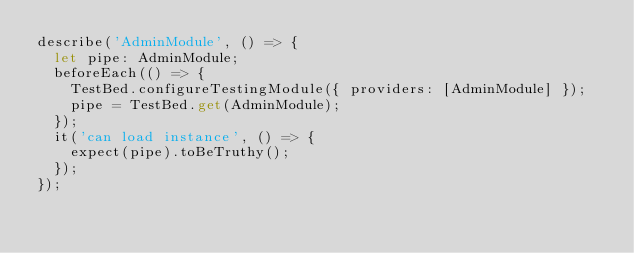<code> <loc_0><loc_0><loc_500><loc_500><_TypeScript_>describe('AdminModule', () => {
  let pipe: AdminModule;
  beforeEach(() => {
    TestBed.configureTestingModule({ providers: [AdminModule] });
    pipe = TestBed.get(AdminModule);
  });
  it('can load instance', () => {
    expect(pipe).toBeTruthy();
  });
});
</code> 